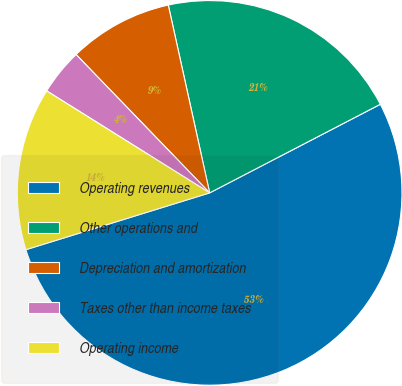Convert chart to OTSL. <chart><loc_0><loc_0><loc_500><loc_500><pie_chart><fcel>Operating revenues<fcel>Other operations and<fcel>Depreciation and amortization<fcel>Taxes other than income taxes<fcel>Operating income<nl><fcel>52.85%<fcel>20.83%<fcel>8.77%<fcel>3.88%<fcel>13.67%<nl></chart> 